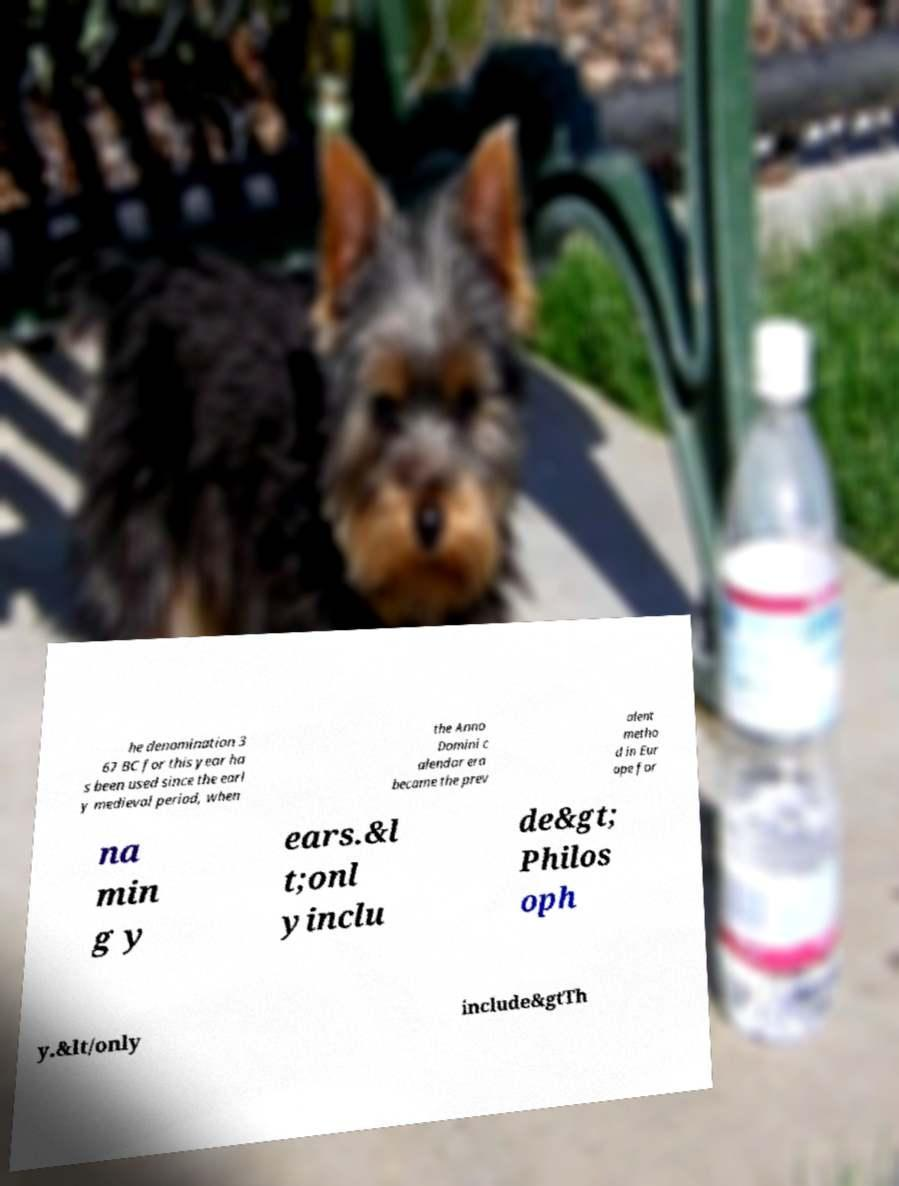Please identify and transcribe the text found in this image. he denomination 3 67 BC for this year ha s been used since the earl y medieval period, when the Anno Domini c alendar era became the prev alent metho d in Eur ope for na min g y ears.&l t;onl yinclu de&gt; Philos oph y.&lt/only include&gtTh 